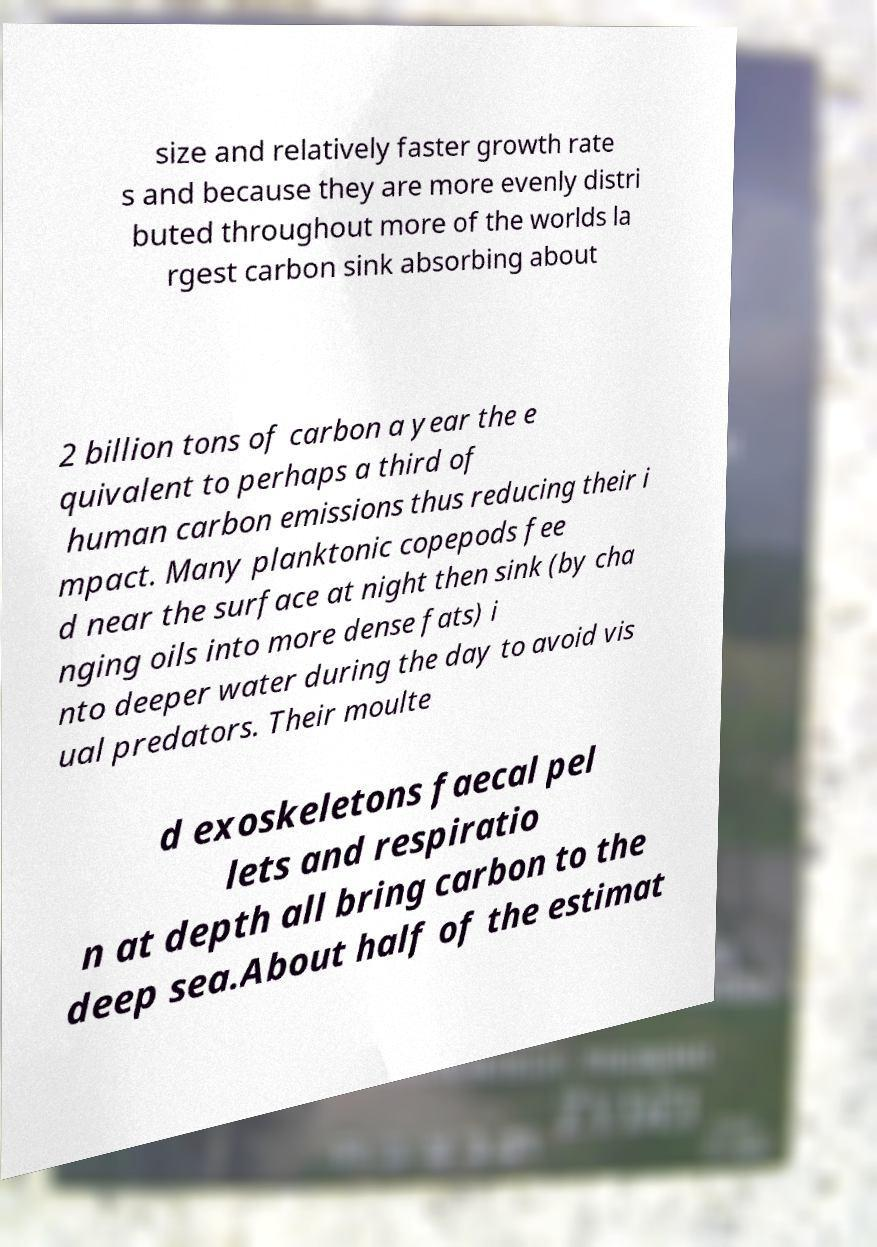Please read and relay the text visible in this image. What does it say? size and relatively faster growth rate s and because they are more evenly distri buted throughout more of the worlds la rgest carbon sink absorbing about 2 billion tons of carbon a year the e quivalent to perhaps a third of human carbon emissions thus reducing their i mpact. Many planktonic copepods fee d near the surface at night then sink (by cha nging oils into more dense fats) i nto deeper water during the day to avoid vis ual predators. Their moulte d exoskeletons faecal pel lets and respiratio n at depth all bring carbon to the deep sea.About half of the estimat 